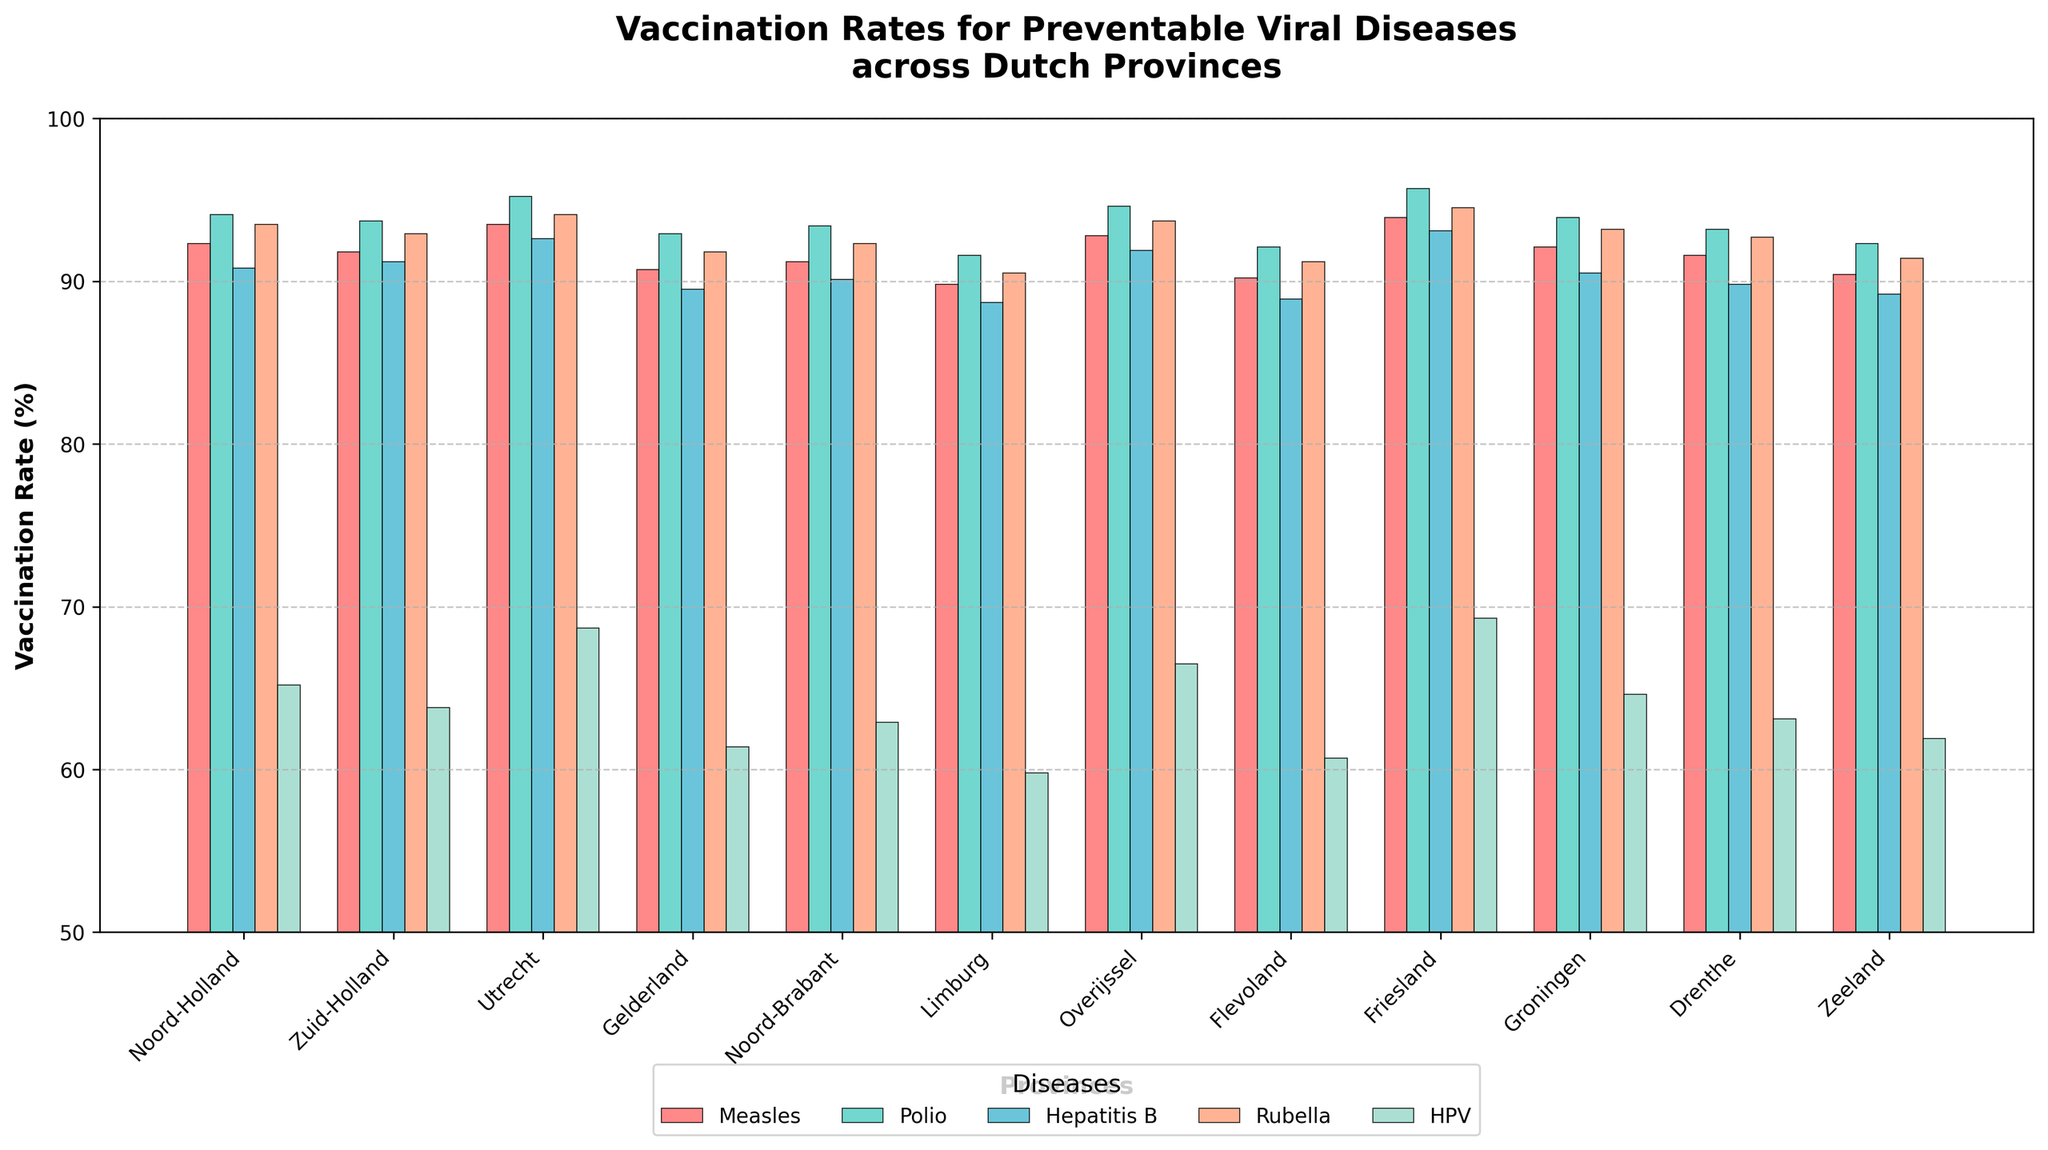Which province has the highest vaccination rate for Measles? Look for the tallest bar in the color representing Measles. Friesland has the tallest bar for Measles.
Answer: Friesland What is the difference in HPV vaccination rates between Utrecht and Limburg? Check the height of the bars for HPV for Utrecht and Limburg, then subtract the lower value from the higher one. Utrecht's HPV rate is 68.7%, and Limburg's is 59.8%. The difference is 68.7 - 59.8 = 8.9%.
Answer: 8.9% Which province shows the lowest vaccination rate for Polio? Look for the shortest bar in the color representing Polio. Limburg has the shortest bar for Polio.
Answer: Limburg What is the average vaccination rate for Hepatitis B in Flevoland, Friesland, and Groningen? Add the Hepatitis B rates for Flevoland (88.9), Friesland (93.1), and Groningen (90.5), then divide by 3. (88.9 + 93.1 + 90.5) / 3 = 90.83%.
Answer: 90.83% Which diseases have higher vaccination rates in Groningen compared to Limburg? Compare the height of the bars for Groningen and Limburg across all diseases. Measles, Polio, Hepatitis B, and Rubella have higher rates in Groningen than in Limburg.
Answer: Measles, Polio, Hepatitis B, Rubella How many provinces have a Measles vaccination rate above 92%? Count the bars in the color representing Measles that exceed the 92% line. There are six provinces: Noord-Holland, Utrecht, Overijssel, Friesland, Groningen, and Drenthe.
Answer: 6 What is the total difference in vaccination rates for all diseases between Noord-Holland and Gelderland? Sum the individual differences in vaccination rates for each disease between Noord-Holland and Gelderland. (92.3-90.7) + (94.1-92.9) + (90.8-89.5) + (93.5-91.8) + (65.2-61.4) = 1.6 + 1.2 + 1.3 + 1.7 + 3.8 = 9.6%.
Answer: 9.6% Which province shows the second highest vaccination rate for Rubella? Identify the second tallest bar in the color representing Rubella. Utrecht (94.1%) is the second highest after Friesland (94.5%).
Answer: Utrecht 